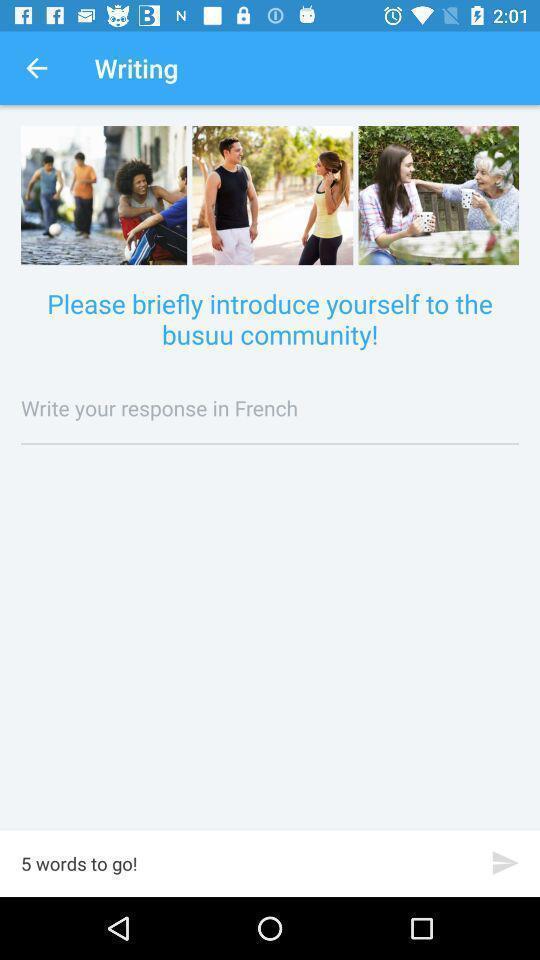Describe the content in this image. Screen displaying the writing page of a language learning app. 